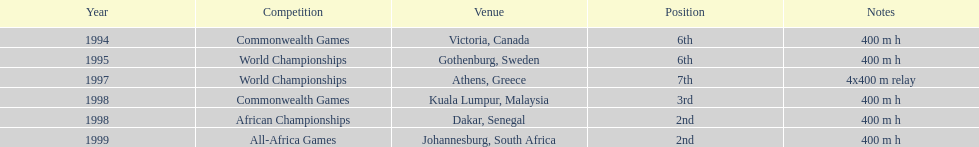Which year had the most competitions? 1998. 